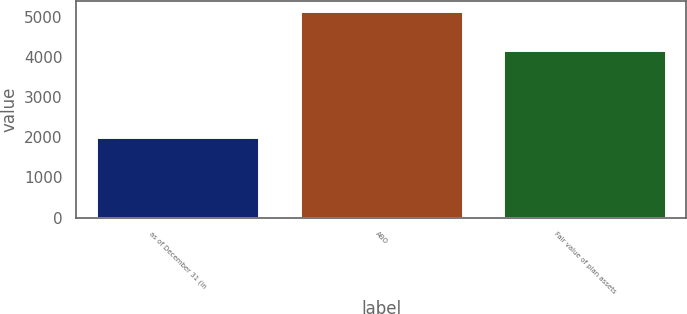Convert chart. <chart><loc_0><loc_0><loc_500><loc_500><bar_chart><fcel>as of December 31 (in<fcel>ABO<fcel>Fair value of plan assets<nl><fcel>2016<fcel>5153<fcel>4190<nl></chart> 